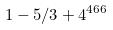Convert formula to latex. <formula><loc_0><loc_0><loc_500><loc_500>1 - 5 / 3 + 4 ^ { 4 6 6 }</formula> 